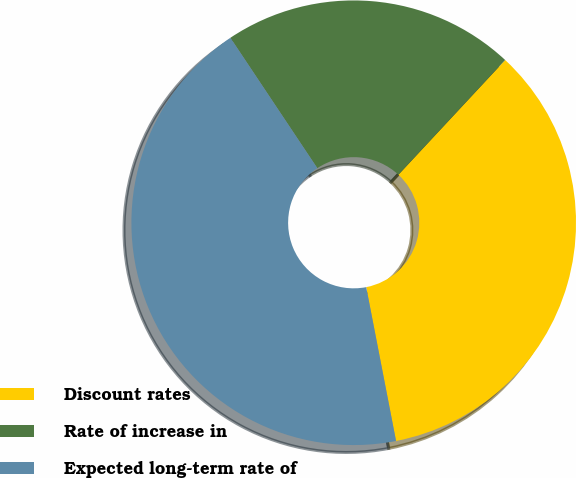Convert chart. <chart><loc_0><loc_0><loc_500><loc_500><pie_chart><fcel>Discount rates<fcel>Rate of increase in<fcel>Expected long-term rate of<nl><fcel>35.02%<fcel>21.29%<fcel>43.69%<nl></chart> 